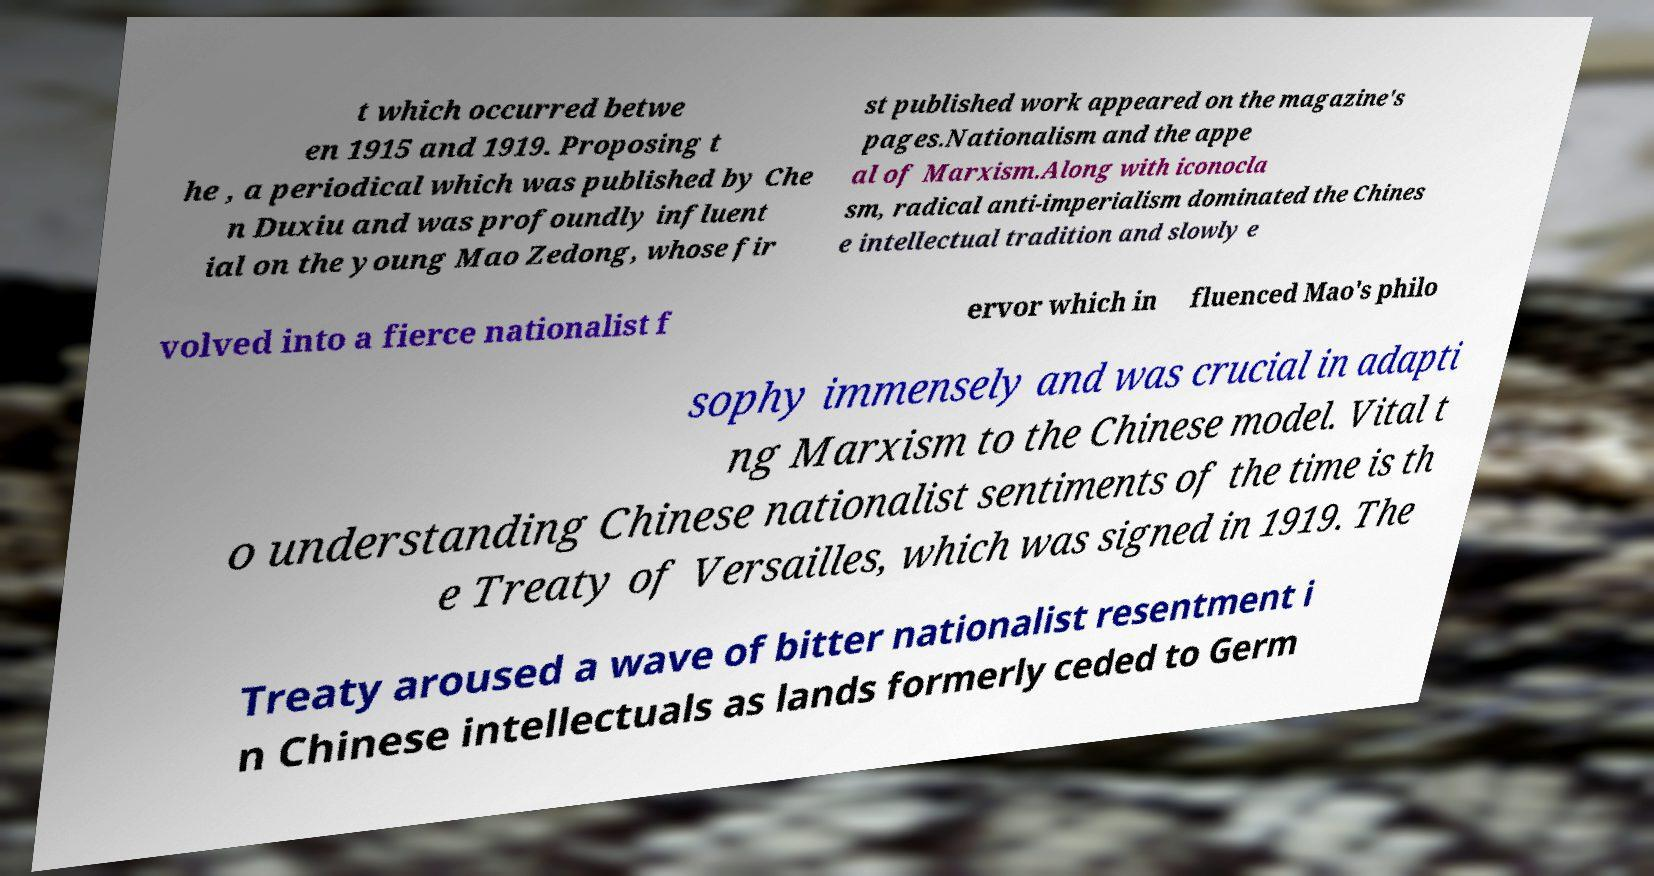There's text embedded in this image that I need extracted. Can you transcribe it verbatim? t which occurred betwe en 1915 and 1919. Proposing t he , a periodical which was published by Che n Duxiu and was profoundly influent ial on the young Mao Zedong, whose fir st published work appeared on the magazine's pages.Nationalism and the appe al of Marxism.Along with iconocla sm, radical anti-imperialism dominated the Chines e intellectual tradition and slowly e volved into a fierce nationalist f ervor which in fluenced Mao's philo sophy immensely and was crucial in adapti ng Marxism to the Chinese model. Vital t o understanding Chinese nationalist sentiments of the time is th e Treaty of Versailles, which was signed in 1919. The Treaty aroused a wave of bitter nationalist resentment i n Chinese intellectuals as lands formerly ceded to Germ 